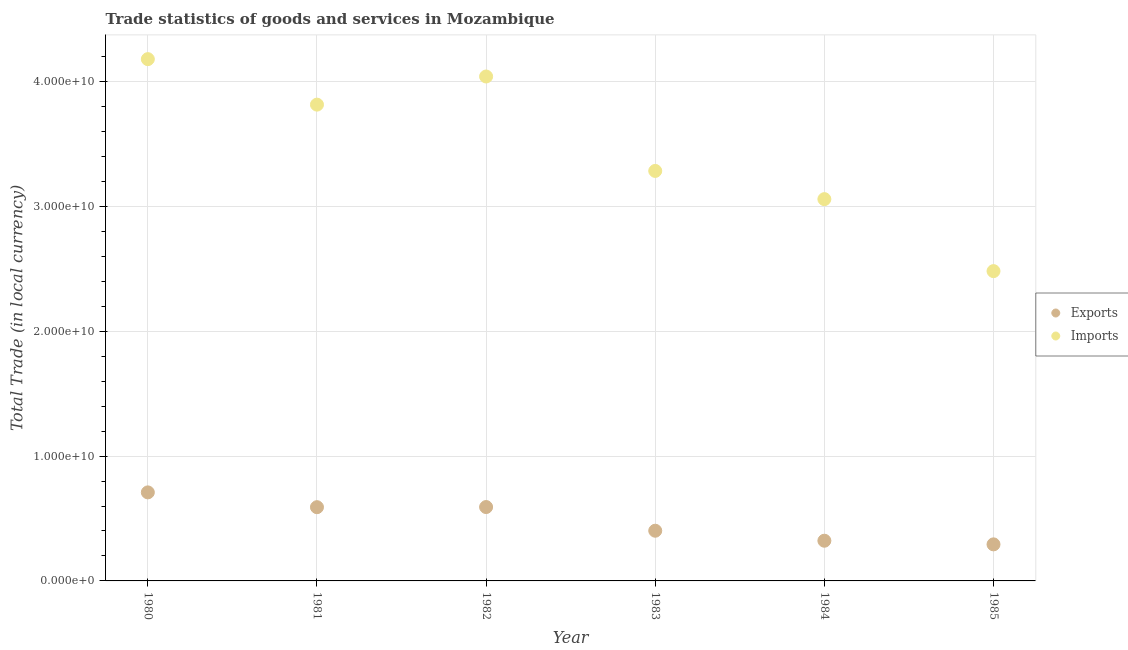How many different coloured dotlines are there?
Ensure brevity in your answer.  2. What is the imports of goods and services in 1981?
Make the answer very short. 3.81e+1. Across all years, what is the maximum imports of goods and services?
Provide a short and direct response. 4.18e+1. Across all years, what is the minimum export of goods and services?
Your response must be concise. 2.93e+09. In which year was the imports of goods and services minimum?
Provide a short and direct response. 1985. What is the total export of goods and services in the graph?
Offer a terse response. 2.91e+1. What is the difference between the imports of goods and services in 1983 and that in 1985?
Provide a short and direct response. 8.02e+09. What is the difference between the export of goods and services in 1981 and the imports of goods and services in 1980?
Your answer should be very brief. -3.59e+1. What is the average imports of goods and services per year?
Keep it short and to the point. 3.48e+1. In the year 1984, what is the difference between the export of goods and services and imports of goods and services?
Your response must be concise. -2.74e+1. What is the ratio of the export of goods and services in 1982 to that in 1984?
Make the answer very short. 1.84. Is the difference between the imports of goods and services in 1982 and 1985 greater than the difference between the export of goods and services in 1982 and 1985?
Provide a short and direct response. Yes. What is the difference between the highest and the second highest imports of goods and services?
Provide a succinct answer. 1.39e+09. What is the difference between the highest and the lowest imports of goods and services?
Offer a terse response. 1.70e+1. In how many years, is the imports of goods and services greater than the average imports of goods and services taken over all years?
Your answer should be very brief. 3. Is the sum of the imports of goods and services in 1982 and 1983 greater than the maximum export of goods and services across all years?
Your answer should be compact. Yes. Does the imports of goods and services monotonically increase over the years?
Keep it short and to the point. No. How many dotlines are there?
Offer a very short reply. 2. How many years are there in the graph?
Your answer should be very brief. 6. Are the values on the major ticks of Y-axis written in scientific E-notation?
Give a very brief answer. Yes. How are the legend labels stacked?
Your response must be concise. Vertical. What is the title of the graph?
Provide a short and direct response. Trade statistics of goods and services in Mozambique. What is the label or title of the X-axis?
Offer a very short reply. Year. What is the label or title of the Y-axis?
Your answer should be very brief. Total Trade (in local currency). What is the Total Trade (in local currency) in Exports in 1980?
Your answer should be compact. 7.09e+09. What is the Total Trade (in local currency) in Imports in 1980?
Keep it short and to the point. 4.18e+1. What is the Total Trade (in local currency) in Exports in 1981?
Ensure brevity in your answer.  5.91e+09. What is the Total Trade (in local currency) of Imports in 1981?
Your answer should be compact. 3.81e+1. What is the Total Trade (in local currency) in Exports in 1982?
Keep it short and to the point. 5.92e+09. What is the Total Trade (in local currency) of Imports in 1982?
Your answer should be compact. 4.04e+1. What is the Total Trade (in local currency) of Exports in 1983?
Provide a short and direct response. 4.02e+09. What is the Total Trade (in local currency) in Imports in 1983?
Offer a very short reply. 3.28e+1. What is the Total Trade (in local currency) of Exports in 1984?
Your answer should be compact. 3.22e+09. What is the Total Trade (in local currency) in Imports in 1984?
Offer a very short reply. 3.06e+1. What is the Total Trade (in local currency) of Exports in 1985?
Provide a short and direct response. 2.93e+09. What is the Total Trade (in local currency) in Imports in 1985?
Your answer should be compact. 2.48e+1. Across all years, what is the maximum Total Trade (in local currency) in Exports?
Ensure brevity in your answer.  7.09e+09. Across all years, what is the maximum Total Trade (in local currency) in Imports?
Give a very brief answer. 4.18e+1. Across all years, what is the minimum Total Trade (in local currency) of Exports?
Provide a short and direct response. 2.93e+09. Across all years, what is the minimum Total Trade (in local currency) in Imports?
Keep it short and to the point. 2.48e+1. What is the total Total Trade (in local currency) in Exports in the graph?
Provide a succinct answer. 2.91e+1. What is the total Total Trade (in local currency) in Imports in the graph?
Offer a very short reply. 2.09e+11. What is the difference between the Total Trade (in local currency) of Exports in 1980 and that in 1981?
Offer a very short reply. 1.19e+09. What is the difference between the Total Trade (in local currency) in Imports in 1980 and that in 1981?
Provide a succinct answer. 3.64e+09. What is the difference between the Total Trade (in local currency) in Exports in 1980 and that in 1982?
Give a very brief answer. 1.17e+09. What is the difference between the Total Trade (in local currency) in Imports in 1980 and that in 1982?
Provide a short and direct response. 1.39e+09. What is the difference between the Total Trade (in local currency) of Exports in 1980 and that in 1983?
Your answer should be compact. 3.07e+09. What is the difference between the Total Trade (in local currency) in Imports in 1980 and that in 1983?
Your answer should be very brief. 8.95e+09. What is the difference between the Total Trade (in local currency) in Exports in 1980 and that in 1984?
Ensure brevity in your answer.  3.87e+09. What is the difference between the Total Trade (in local currency) of Imports in 1980 and that in 1984?
Your answer should be very brief. 1.12e+1. What is the difference between the Total Trade (in local currency) in Exports in 1980 and that in 1985?
Make the answer very short. 4.16e+09. What is the difference between the Total Trade (in local currency) of Imports in 1980 and that in 1985?
Offer a very short reply. 1.70e+1. What is the difference between the Total Trade (in local currency) in Exports in 1981 and that in 1982?
Give a very brief answer. -1.13e+07. What is the difference between the Total Trade (in local currency) in Imports in 1981 and that in 1982?
Offer a very short reply. -2.25e+09. What is the difference between the Total Trade (in local currency) of Exports in 1981 and that in 1983?
Provide a succinct answer. 1.89e+09. What is the difference between the Total Trade (in local currency) in Imports in 1981 and that in 1983?
Your response must be concise. 5.31e+09. What is the difference between the Total Trade (in local currency) in Exports in 1981 and that in 1984?
Give a very brief answer. 2.69e+09. What is the difference between the Total Trade (in local currency) of Imports in 1981 and that in 1984?
Offer a terse response. 7.57e+09. What is the difference between the Total Trade (in local currency) of Exports in 1981 and that in 1985?
Provide a succinct answer. 2.98e+09. What is the difference between the Total Trade (in local currency) in Imports in 1981 and that in 1985?
Provide a succinct answer. 1.33e+1. What is the difference between the Total Trade (in local currency) in Exports in 1982 and that in 1983?
Your answer should be very brief. 1.90e+09. What is the difference between the Total Trade (in local currency) of Imports in 1982 and that in 1983?
Provide a short and direct response. 7.56e+09. What is the difference between the Total Trade (in local currency) in Exports in 1982 and that in 1984?
Provide a short and direct response. 2.70e+09. What is the difference between the Total Trade (in local currency) in Imports in 1982 and that in 1984?
Your response must be concise. 9.82e+09. What is the difference between the Total Trade (in local currency) in Exports in 1982 and that in 1985?
Ensure brevity in your answer.  2.99e+09. What is the difference between the Total Trade (in local currency) in Imports in 1982 and that in 1985?
Keep it short and to the point. 1.56e+1. What is the difference between the Total Trade (in local currency) of Exports in 1983 and that in 1984?
Make the answer very short. 8.00e+08. What is the difference between the Total Trade (in local currency) in Imports in 1983 and that in 1984?
Your answer should be compact. 2.26e+09. What is the difference between the Total Trade (in local currency) of Exports in 1983 and that in 1985?
Provide a succinct answer. 1.09e+09. What is the difference between the Total Trade (in local currency) of Imports in 1983 and that in 1985?
Your answer should be compact. 8.02e+09. What is the difference between the Total Trade (in local currency) of Exports in 1984 and that in 1985?
Provide a short and direct response. 2.92e+08. What is the difference between the Total Trade (in local currency) in Imports in 1984 and that in 1985?
Ensure brevity in your answer.  5.76e+09. What is the difference between the Total Trade (in local currency) in Exports in 1980 and the Total Trade (in local currency) in Imports in 1981?
Keep it short and to the point. -3.11e+1. What is the difference between the Total Trade (in local currency) of Exports in 1980 and the Total Trade (in local currency) of Imports in 1982?
Give a very brief answer. -3.33e+1. What is the difference between the Total Trade (in local currency) in Exports in 1980 and the Total Trade (in local currency) in Imports in 1983?
Your response must be concise. -2.57e+1. What is the difference between the Total Trade (in local currency) in Exports in 1980 and the Total Trade (in local currency) in Imports in 1984?
Offer a very short reply. -2.35e+1. What is the difference between the Total Trade (in local currency) in Exports in 1980 and the Total Trade (in local currency) in Imports in 1985?
Ensure brevity in your answer.  -1.77e+1. What is the difference between the Total Trade (in local currency) of Exports in 1981 and the Total Trade (in local currency) of Imports in 1982?
Give a very brief answer. -3.45e+1. What is the difference between the Total Trade (in local currency) of Exports in 1981 and the Total Trade (in local currency) of Imports in 1983?
Your answer should be compact. -2.69e+1. What is the difference between the Total Trade (in local currency) in Exports in 1981 and the Total Trade (in local currency) in Imports in 1984?
Provide a short and direct response. -2.47e+1. What is the difference between the Total Trade (in local currency) of Exports in 1981 and the Total Trade (in local currency) of Imports in 1985?
Your answer should be compact. -1.89e+1. What is the difference between the Total Trade (in local currency) of Exports in 1982 and the Total Trade (in local currency) of Imports in 1983?
Give a very brief answer. -2.69e+1. What is the difference between the Total Trade (in local currency) in Exports in 1982 and the Total Trade (in local currency) in Imports in 1984?
Your response must be concise. -2.47e+1. What is the difference between the Total Trade (in local currency) of Exports in 1982 and the Total Trade (in local currency) of Imports in 1985?
Keep it short and to the point. -1.89e+1. What is the difference between the Total Trade (in local currency) in Exports in 1983 and the Total Trade (in local currency) in Imports in 1984?
Keep it short and to the point. -2.66e+1. What is the difference between the Total Trade (in local currency) of Exports in 1983 and the Total Trade (in local currency) of Imports in 1985?
Your answer should be very brief. -2.08e+1. What is the difference between the Total Trade (in local currency) in Exports in 1984 and the Total Trade (in local currency) in Imports in 1985?
Make the answer very short. -2.16e+1. What is the average Total Trade (in local currency) of Exports per year?
Give a very brief answer. 4.85e+09. What is the average Total Trade (in local currency) of Imports per year?
Keep it short and to the point. 3.48e+1. In the year 1980, what is the difference between the Total Trade (in local currency) in Exports and Total Trade (in local currency) in Imports?
Offer a terse response. -3.47e+1. In the year 1981, what is the difference between the Total Trade (in local currency) of Exports and Total Trade (in local currency) of Imports?
Offer a terse response. -3.22e+1. In the year 1982, what is the difference between the Total Trade (in local currency) in Exports and Total Trade (in local currency) in Imports?
Your answer should be compact. -3.45e+1. In the year 1983, what is the difference between the Total Trade (in local currency) in Exports and Total Trade (in local currency) in Imports?
Give a very brief answer. -2.88e+1. In the year 1984, what is the difference between the Total Trade (in local currency) in Exports and Total Trade (in local currency) in Imports?
Keep it short and to the point. -2.74e+1. In the year 1985, what is the difference between the Total Trade (in local currency) of Exports and Total Trade (in local currency) of Imports?
Provide a succinct answer. -2.19e+1. What is the ratio of the Total Trade (in local currency) in Exports in 1980 to that in 1981?
Your response must be concise. 1.2. What is the ratio of the Total Trade (in local currency) of Imports in 1980 to that in 1981?
Make the answer very short. 1.1. What is the ratio of the Total Trade (in local currency) in Exports in 1980 to that in 1982?
Your response must be concise. 1.2. What is the ratio of the Total Trade (in local currency) in Imports in 1980 to that in 1982?
Provide a short and direct response. 1.03. What is the ratio of the Total Trade (in local currency) in Exports in 1980 to that in 1983?
Make the answer very short. 1.76. What is the ratio of the Total Trade (in local currency) of Imports in 1980 to that in 1983?
Provide a short and direct response. 1.27. What is the ratio of the Total Trade (in local currency) of Exports in 1980 to that in 1984?
Your answer should be very brief. 2.2. What is the ratio of the Total Trade (in local currency) of Imports in 1980 to that in 1984?
Your response must be concise. 1.37. What is the ratio of the Total Trade (in local currency) of Exports in 1980 to that in 1985?
Give a very brief answer. 2.42. What is the ratio of the Total Trade (in local currency) in Imports in 1980 to that in 1985?
Your answer should be compact. 1.68. What is the ratio of the Total Trade (in local currency) of Imports in 1981 to that in 1982?
Your answer should be compact. 0.94. What is the ratio of the Total Trade (in local currency) of Exports in 1981 to that in 1983?
Offer a very short reply. 1.47. What is the ratio of the Total Trade (in local currency) of Imports in 1981 to that in 1983?
Offer a very short reply. 1.16. What is the ratio of the Total Trade (in local currency) of Exports in 1981 to that in 1984?
Your answer should be very brief. 1.83. What is the ratio of the Total Trade (in local currency) in Imports in 1981 to that in 1984?
Ensure brevity in your answer.  1.25. What is the ratio of the Total Trade (in local currency) in Exports in 1981 to that in 1985?
Your answer should be very brief. 2.02. What is the ratio of the Total Trade (in local currency) in Imports in 1981 to that in 1985?
Your answer should be very brief. 1.54. What is the ratio of the Total Trade (in local currency) of Exports in 1982 to that in 1983?
Keep it short and to the point. 1.47. What is the ratio of the Total Trade (in local currency) in Imports in 1982 to that in 1983?
Give a very brief answer. 1.23. What is the ratio of the Total Trade (in local currency) of Exports in 1982 to that in 1984?
Your response must be concise. 1.84. What is the ratio of the Total Trade (in local currency) in Imports in 1982 to that in 1984?
Keep it short and to the point. 1.32. What is the ratio of the Total Trade (in local currency) in Exports in 1982 to that in 1985?
Ensure brevity in your answer.  2.02. What is the ratio of the Total Trade (in local currency) in Imports in 1982 to that in 1985?
Your answer should be compact. 1.63. What is the ratio of the Total Trade (in local currency) of Exports in 1983 to that in 1984?
Provide a short and direct response. 1.25. What is the ratio of the Total Trade (in local currency) of Imports in 1983 to that in 1984?
Give a very brief answer. 1.07. What is the ratio of the Total Trade (in local currency) of Exports in 1983 to that in 1985?
Ensure brevity in your answer.  1.37. What is the ratio of the Total Trade (in local currency) of Imports in 1983 to that in 1985?
Ensure brevity in your answer.  1.32. What is the ratio of the Total Trade (in local currency) in Exports in 1984 to that in 1985?
Provide a short and direct response. 1.1. What is the ratio of the Total Trade (in local currency) in Imports in 1984 to that in 1985?
Keep it short and to the point. 1.23. What is the difference between the highest and the second highest Total Trade (in local currency) in Exports?
Provide a short and direct response. 1.17e+09. What is the difference between the highest and the second highest Total Trade (in local currency) in Imports?
Offer a very short reply. 1.39e+09. What is the difference between the highest and the lowest Total Trade (in local currency) of Exports?
Offer a terse response. 4.16e+09. What is the difference between the highest and the lowest Total Trade (in local currency) in Imports?
Offer a very short reply. 1.70e+1. 